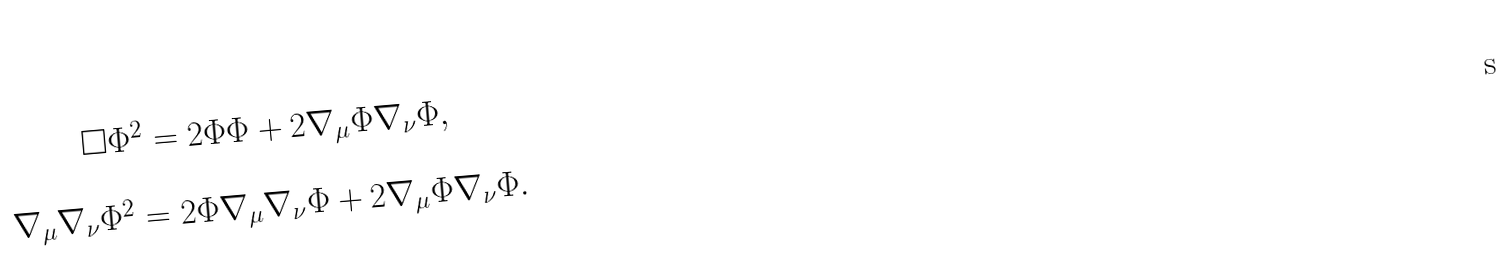Convert formula to latex. <formula><loc_0><loc_0><loc_500><loc_500>\begin{array} { c } \Box \Phi ^ { 2 } = 2 \Phi \Phi + 2 \nabla _ { \mu } \Phi \nabla _ { \nu } \Phi , \\ \\ \nabla _ { \mu } \nabla _ { \nu } \Phi ^ { 2 } = 2 \Phi \nabla _ { \mu } \nabla _ { \nu } \Phi + 2 \nabla _ { \mu } \Phi \nabla _ { \nu } \Phi . \end{array}</formula> 